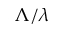<formula> <loc_0><loc_0><loc_500><loc_500>\Lambda / \lambda</formula> 